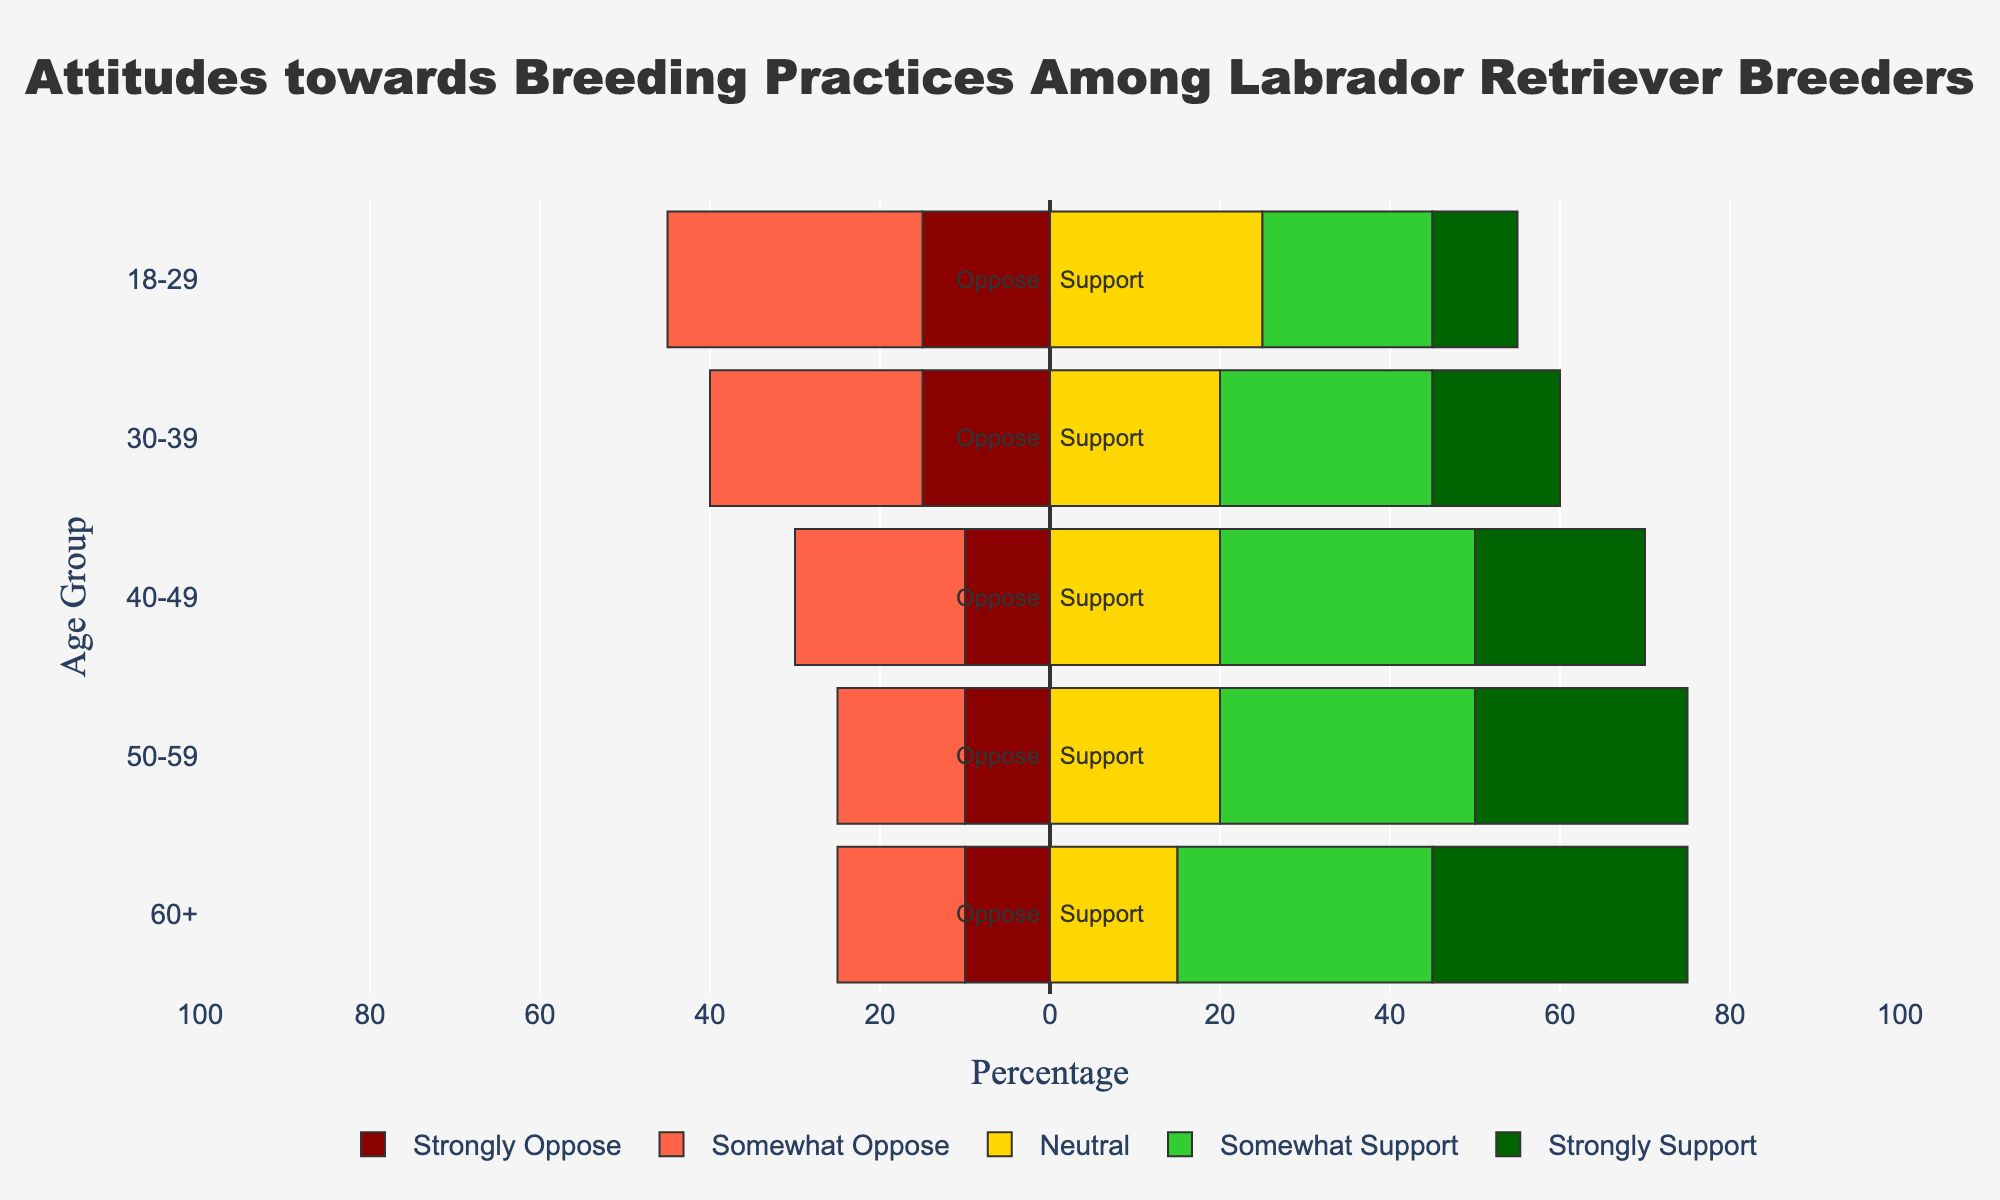Which age group has the highest percentage of "Strongly Support" attitude towards breeding practices? Look at the "Strongly Support" segment in the bar and compare the lengths for each age group. The 60+ age group has the longest "Strongly Support" segment, indicating the highest percentage.
Answer: 60+ What is the total percentage of breeders in the 50-59 age group who either "Somewhat Support" or "Strongly Support" breeding practices? Add the percentages of "Somewhat Support" and "Strongly Support" for the 50-59 age group: 30% (Somewhat Support) + 25% (Strongly Support).
Answer: 55% Which age group has the smallest overall opposition (combining "Somewhat Oppose" and "Strongly Oppose") to breeding practices? Calculate the sum of "Somewhat Oppose" and "Strongly Oppose" percentages for each age group, and compare them: 18-29: 30% + 15% = 45%, 30-39: 25% + 15% = 40%, 40-49: 20% + 10% = 30%, 50-59: 15% + 10% = 25%, 60+: 15% + 10% = 25%. The smallest total opposition is in the 50-59 and 60+ age groups.
Answer: 50-59 and 60+ Is there any age group where the "Neutral" attitude is the most dominant? Check if the "Neutral" segment is the largest part of the bar for any age group. None of the age groups show "Neutral" as the largest segment.
Answer: No How does the "Somewhat Support" percentage compare between the 30-39 and 40-49 age groups? Look at the "Somewhat Support" segments and compare their lengths for the 30-39 and 40-49 age groups. The 40-49 age group has a longer "Somewhat Support" segment (30%) compared to the 30-39 age group (25%).
Answer: 40-49 > 30-39 What is the combined percentage of breeders in the 18-29 age group who are either neutral or oppose breeding practices? Add the percentages of "Neutral", "Somewhat Oppose", and "Strongly Oppose" for the 18-29 age group: 25% (Neutral) + 30% (Somewhat Oppose) + 15% (Strongly Oppose).
Answer: 70% In which age group does the "Strongly Oppose" attitude have the smallest percentage? Compare the lengths of the "Strongly Oppose" segments for each age group. The 40-49, 50-59, and 60+ age group have the smallest "Strongly Oppose" percentage (10%).
Answer: 40-49, 50-59, 60+ How does the overall support (combining "Somewhat Support" and "Strongly Support") for breeding practices in the 30-39 age group compare to that of the 50-59 age group? Calculate the sum of "Somewhat Support" and "Strongly Support" for both age groups, then compare: 30-39: 25% + 15% = 40%, 50-59: 30% + 25% = 55%.
Answer: 50-59 > 30-39 